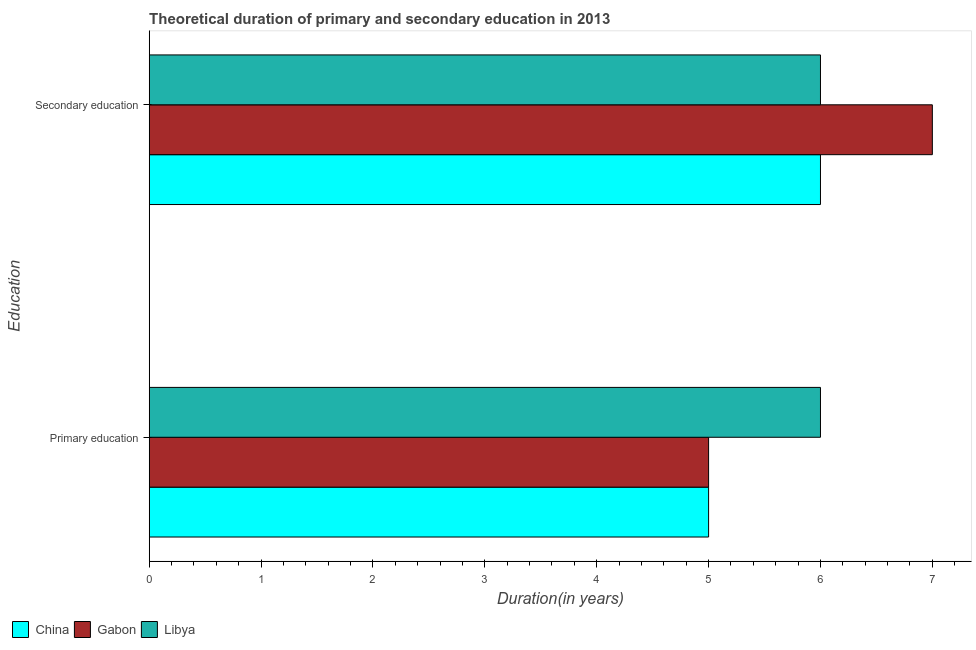How many different coloured bars are there?
Offer a very short reply. 3. How many groups of bars are there?
Give a very brief answer. 2. How many bars are there on the 2nd tick from the bottom?
Ensure brevity in your answer.  3. What is the duration of primary education in China?
Give a very brief answer. 5. Across all countries, what is the maximum duration of secondary education?
Offer a very short reply. 7. In which country was the duration of secondary education maximum?
Offer a very short reply. Gabon. In which country was the duration of primary education minimum?
Make the answer very short. China. What is the total duration of secondary education in the graph?
Provide a short and direct response. 19. What is the difference between the duration of secondary education in China and that in Libya?
Your answer should be compact. 0. What is the average duration of primary education per country?
Give a very brief answer. 5.33. In how many countries, is the duration of secondary education greater than 2 years?
Ensure brevity in your answer.  3. What is the ratio of the duration of secondary education in Libya to that in Gabon?
Your answer should be very brief. 0.86. In how many countries, is the duration of secondary education greater than the average duration of secondary education taken over all countries?
Make the answer very short. 1. What does the 2nd bar from the top in Secondary education represents?
Ensure brevity in your answer.  Gabon. What does the 3rd bar from the bottom in Secondary education represents?
Provide a succinct answer. Libya. How many bars are there?
Your answer should be compact. 6. How many countries are there in the graph?
Offer a terse response. 3. Are the values on the major ticks of X-axis written in scientific E-notation?
Give a very brief answer. No. What is the title of the graph?
Ensure brevity in your answer.  Theoretical duration of primary and secondary education in 2013. What is the label or title of the X-axis?
Your response must be concise. Duration(in years). What is the label or title of the Y-axis?
Offer a terse response. Education. What is the Duration(in years) in Gabon in Primary education?
Your answer should be compact. 5. What is the Duration(in years) in China in Secondary education?
Provide a short and direct response. 6. What is the Duration(in years) in Gabon in Secondary education?
Ensure brevity in your answer.  7. What is the Duration(in years) of Libya in Secondary education?
Your answer should be compact. 6. Across all Education, what is the maximum Duration(in years) of China?
Make the answer very short. 6. Across all Education, what is the maximum Duration(in years) of Gabon?
Your response must be concise. 7. What is the total Duration(in years) of Gabon in the graph?
Provide a succinct answer. 12. What is the total Duration(in years) in Libya in the graph?
Make the answer very short. 12. What is the difference between the Duration(in years) of China in Primary education and that in Secondary education?
Ensure brevity in your answer.  -1. What is the difference between the Duration(in years) of Gabon in Primary education and that in Secondary education?
Your answer should be very brief. -2. What is the difference between the Duration(in years) in Libya in Primary education and that in Secondary education?
Offer a terse response. 0. What is the average Duration(in years) of Gabon per Education?
Keep it short and to the point. 6. What is the average Duration(in years) in Libya per Education?
Provide a succinct answer. 6. What is the difference between the Duration(in years) in China and Duration(in years) in Gabon in Primary education?
Your response must be concise. 0. What is the difference between the Duration(in years) in China and Duration(in years) in Libya in Secondary education?
Your answer should be compact. 0. What is the ratio of the Duration(in years) in China in Primary education to that in Secondary education?
Your answer should be compact. 0.83. What is the difference between the highest and the second highest Duration(in years) of China?
Your answer should be compact. 1. What is the difference between the highest and the second highest Duration(in years) of Gabon?
Offer a terse response. 2. What is the difference between the highest and the second highest Duration(in years) in Libya?
Keep it short and to the point. 0. What is the difference between the highest and the lowest Duration(in years) in China?
Ensure brevity in your answer.  1. What is the difference between the highest and the lowest Duration(in years) of Gabon?
Keep it short and to the point. 2. What is the difference between the highest and the lowest Duration(in years) of Libya?
Give a very brief answer. 0. 